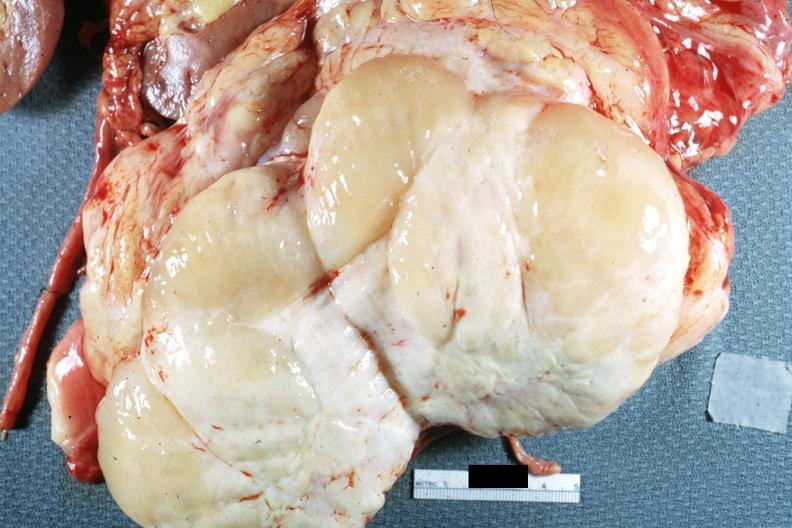what is present?
Answer the question using a single word or phrase. Retroperitoneal liposarcoma 